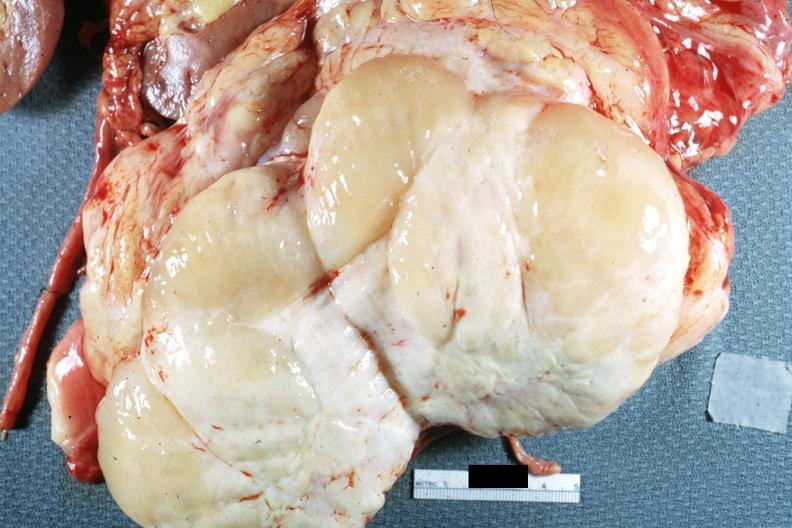what is present?
Answer the question using a single word or phrase. Retroperitoneal liposarcoma 